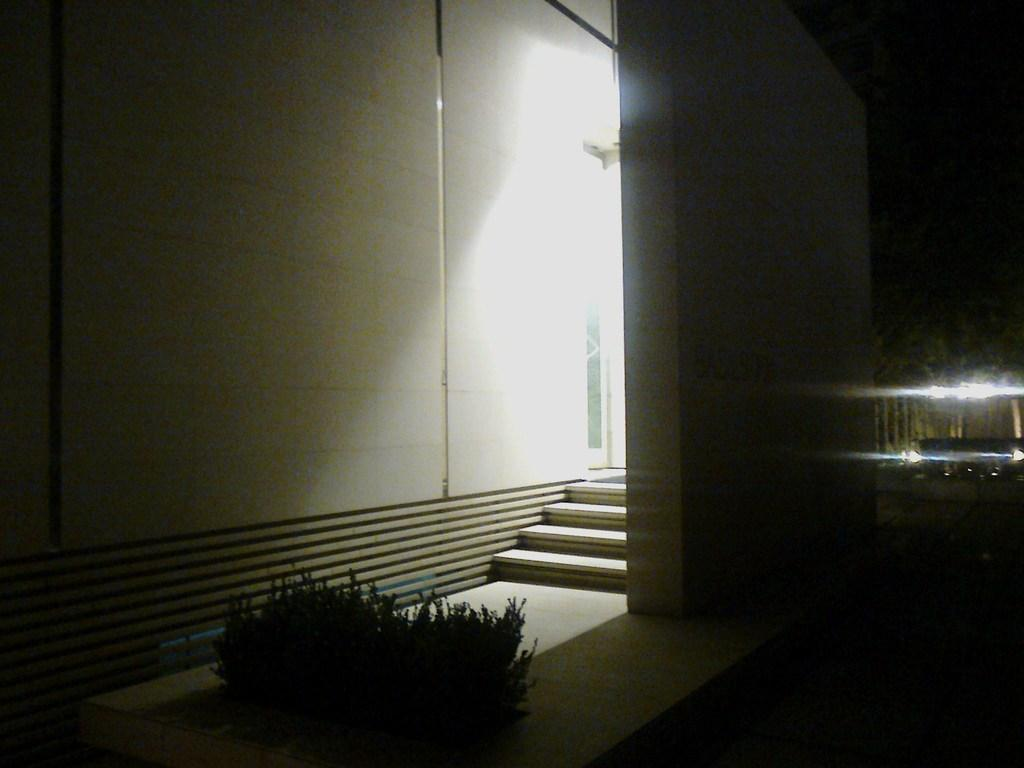What can be seen on the ground in the image? The floor is visible in the image. What type of vegetation is present in the image? There are plants in the image. What architectural feature is depicted in the image? There are steps in the image. What type of structure is visible in the image? There are walls in the image. What type of illumination is present in the image? There are lights in the image. What other items can be seen in the image? There are some objects in the image. How would you describe the overall lighting in the image? The background of the image is dark. What direction is the daughter facing in the image? There is no daughter present in the image. What type of door is visible in the image? There is no door present in the image. 